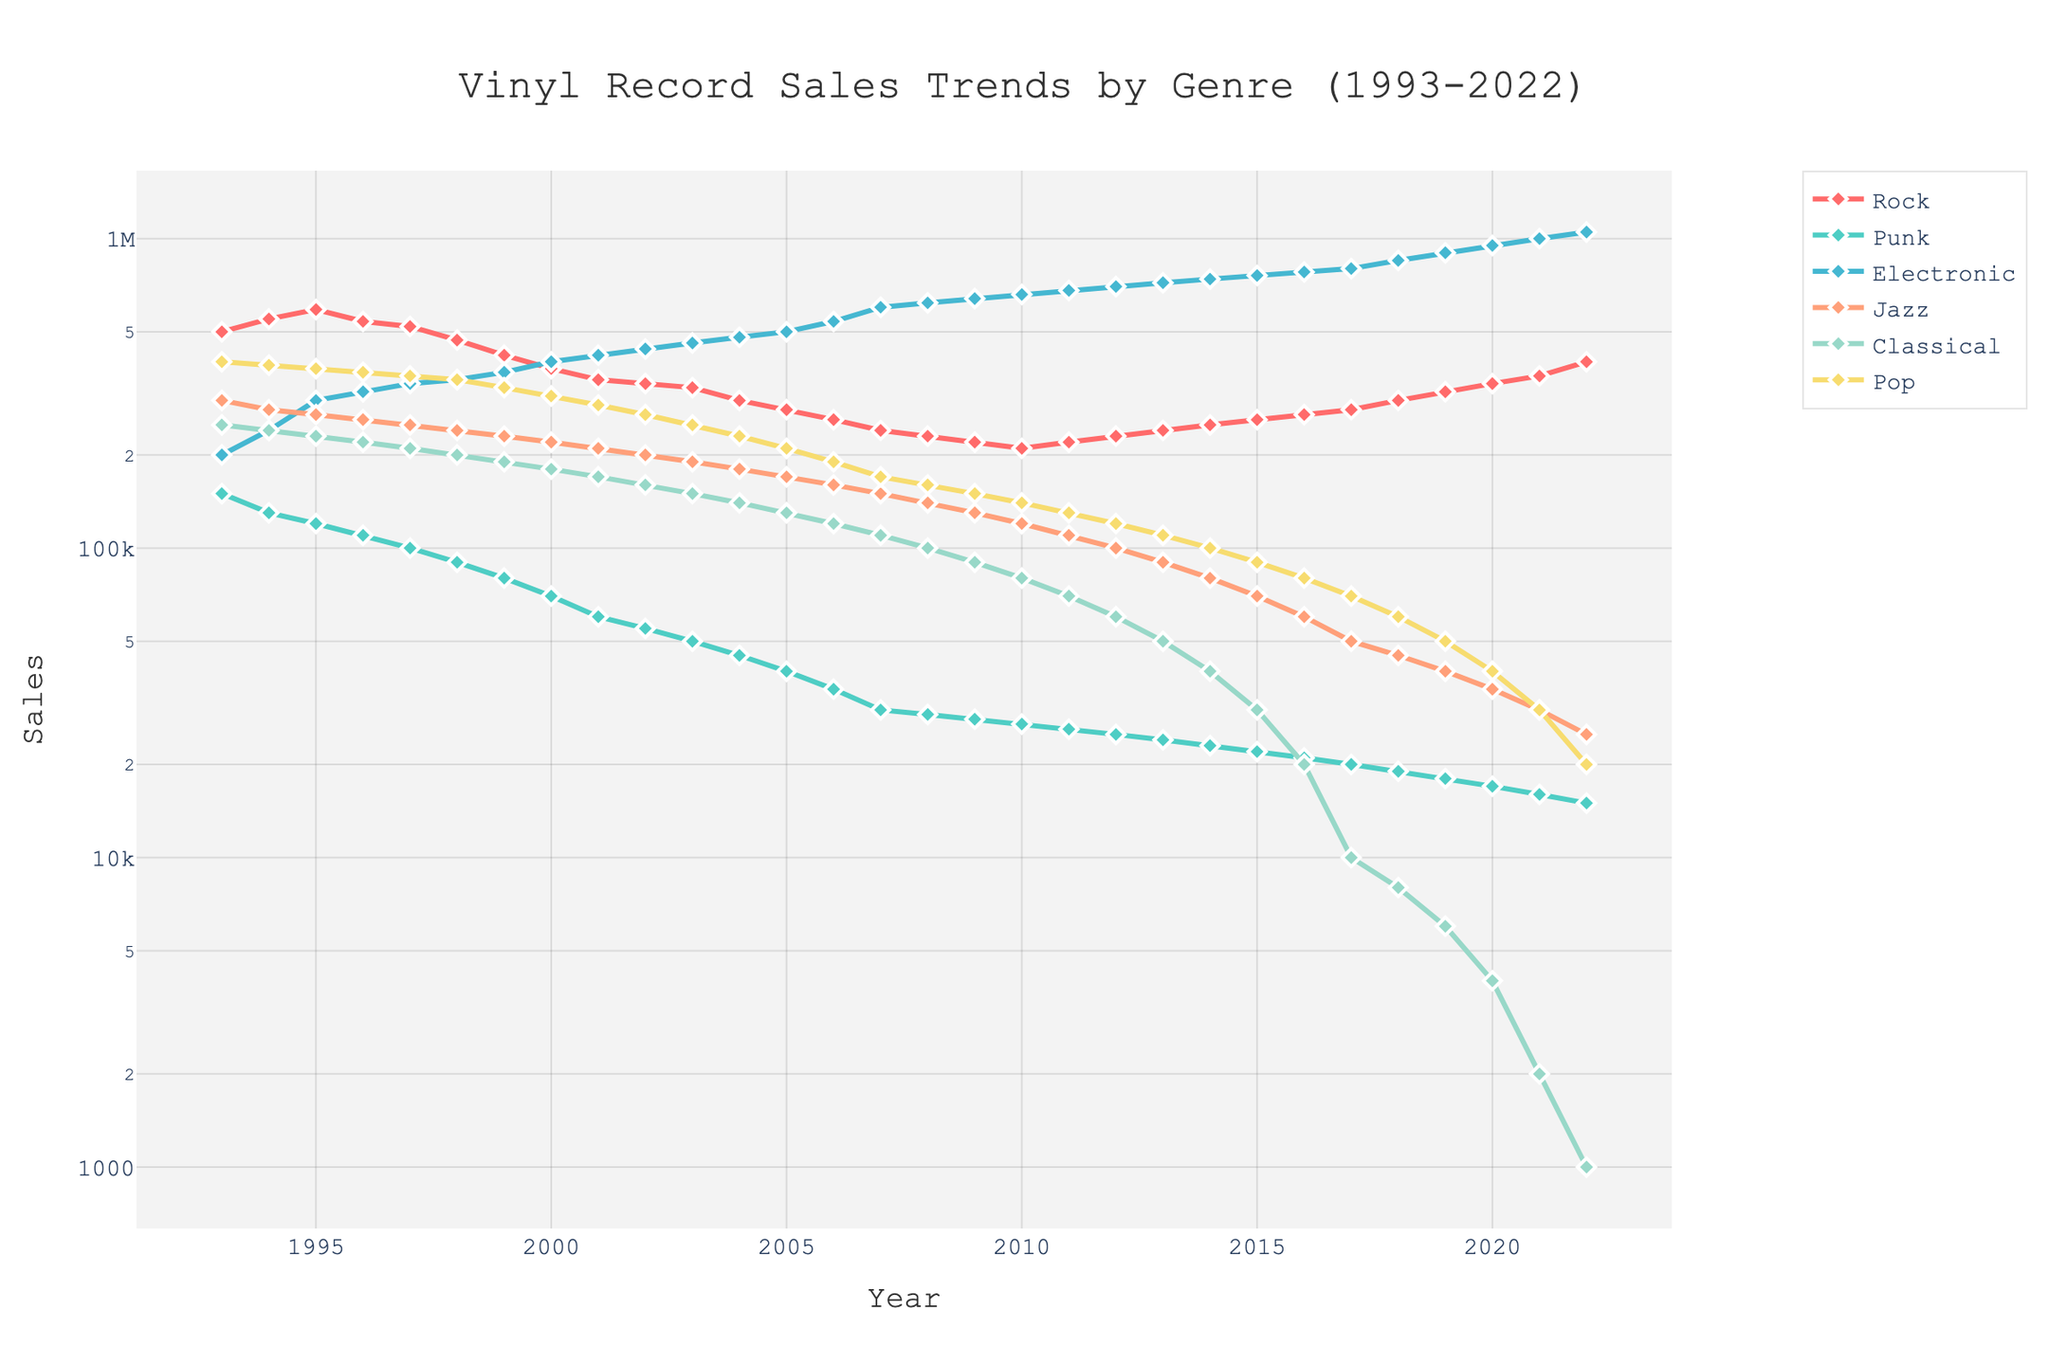Which genre has shown the most substantial growth in vinyl record sales over the past 30 years? Looking at the trend lines for the different genres, Electronic music shows the steepest increase in sales over the 30-year period, starting from almost the same level as other genres in 1993 but reaching the highest point by 2022.
Answer: Electronic What is the range of vinyl record sales for Rock music between 1993 and 2022? The lowest sales value for Rock is observed around 2008 at 230,000 records, and the highest is in 1995 at 590,000 records. The range is calculated as 590,000 - 230,000.
Answer: 360,000 During which period did vinyl record sales for Jazz show a steady decline? By observing the Jazz line, we see a consistent downward pattern between 1993 and around 2017, before a slight increase begins.
Answer: 1993-2017 Which genre had the lowest sales in 2022, and what is the sales value? The Classical genre marked the lowest sales in 2022, as indicated by the line hitting the lowest point on the y-axis (log scale). The sales value was approximately 1,000 records.
Answer: Classical, 1,000 What is the overall trend for Punk music sales from 1993 to 2022? The line for Punk music sales shows a clear downward trend, decreasing consistently from 150,000 records in 1993 to about 15,000 in 2022.
Answer: Decreasing How do vinyl record sales in 2000 for Pop compare to Electronic? Comparing the data points, Pop sales in 2000 were around 310,000, whereas Electronic sales were 400,000, making Electronic higher.
Answer: Higher What is the relative difference in sales between Rock and Electronic in 1999? Sales for Rock in 1999 were 420,000 and for Electronic were 370,000. The relative difference is calculated as (420,000 - 370,000) / 370,000 = 13.5%.
Answer: 13.5% Which year marks the first point where Electronic music sales surpass all other genres? Reviewing the trend lines, Electronic music sales surpass all other genres for the first time around the year 2007.
Answer: 2007 What are the sales for Classical music in 2010, and how does it compare to its sales in 2022? Classical music sales in 2010 were about 80,000, whereas by 2022, they had significantly decreased to around 1,000.
Answer: 80,000 in 2010; significantly decreased to 1,000 in 2022 How did Rock music sales fluctuate between 1997 and 2007? The line for Rock music sales shows a decline from 520,000 in 1997 to 240,000 in 2007, indicating a steady decline over this period.
Answer: Declined steadily 